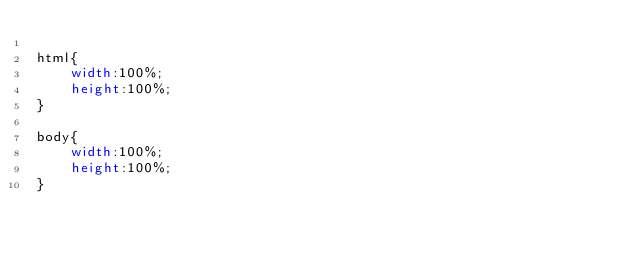<code> <loc_0><loc_0><loc_500><loc_500><_CSS_>
html{
    width:100%;
    height:100%;
}

body{
    width:100%;
    height:100%;
}</code> 